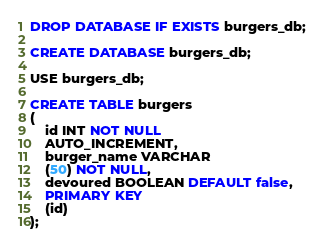<code> <loc_0><loc_0><loc_500><loc_500><_SQL_>DROP DATABASE IF EXISTS burgers_db;

CREATE DATABASE burgers_db;

USE burgers_db;

CREATE TABLE burgers
(
    id INT NOT NULL
    AUTO_INCREMENT,
    burger_name VARCHAR
    (50) NOT NULL,
    devoured BOOLEAN DEFAULT false,
    PRIMARY KEY
    (id)
);</code> 